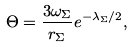Convert formula to latex. <formula><loc_0><loc_0><loc_500><loc_500>\Theta = \frac { 3 \omega _ { \Sigma } } { r _ { \Sigma } } e ^ { - \lambda _ { \Sigma } / 2 } ,</formula> 